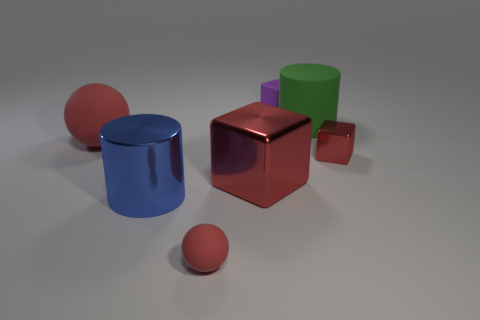Subtract all big cubes. How many cubes are left? 2 Add 1 large spheres. How many objects exist? 8 Subtract 1 spheres. How many spheres are left? 1 Subtract all purple blocks. How many blocks are left? 2 Subtract all balls. How many objects are left? 5 Subtract all cyan balls. How many brown blocks are left? 0 Subtract all red cylinders. Subtract all yellow balls. How many cylinders are left? 2 Subtract all small rubber spheres. Subtract all small cyan matte cylinders. How many objects are left? 6 Add 4 large blue shiny objects. How many large blue shiny objects are left? 5 Add 7 small yellow matte cubes. How many small yellow matte cubes exist? 7 